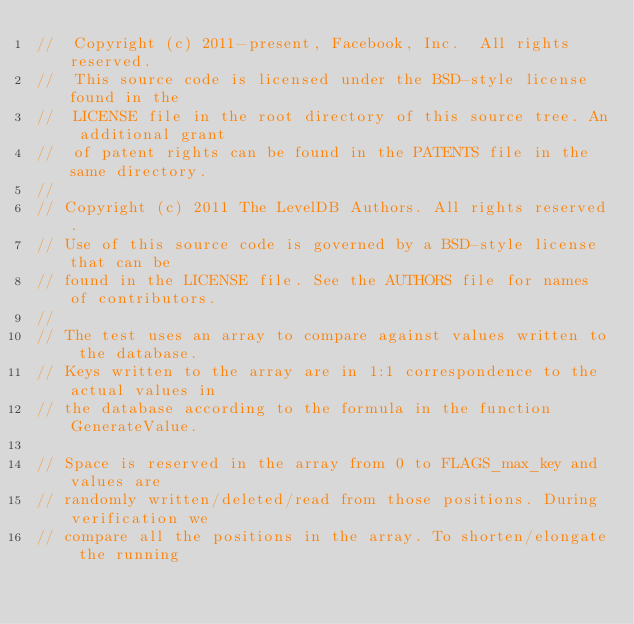<code> <loc_0><loc_0><loc_500><loc_500><_C++_>//  Copyright (c) 2011-present, Facebook, Inc.  All rights reserved.
//  This source code is licensed under the BSD-style license found in the
//  LICENSE file in the root directory of this source tree. An additional grant
//  of patent rights can be found in the PATENTS file in the same directory.
//
// Copyright (c) 2011 The LevelDB Authors. All rights reserved.
// Use of this source code is governed by a BSD-style license that can be
// found in the LICENSE file. See the AUTHORS file for names of contributors.
//
// The test uses an array to compare against values written to the database.
// Keys written to the array are in 1:1 correspondence to the actual values in
// the database according to the formula in the function GenerateValue.

// Space is reserved in the array from 0 to FLAGS_max_key and values are
// randomly written/deleted/read from those positions. During verification we
// compare all the positions in the array. To shorten/elongate the running</code> 